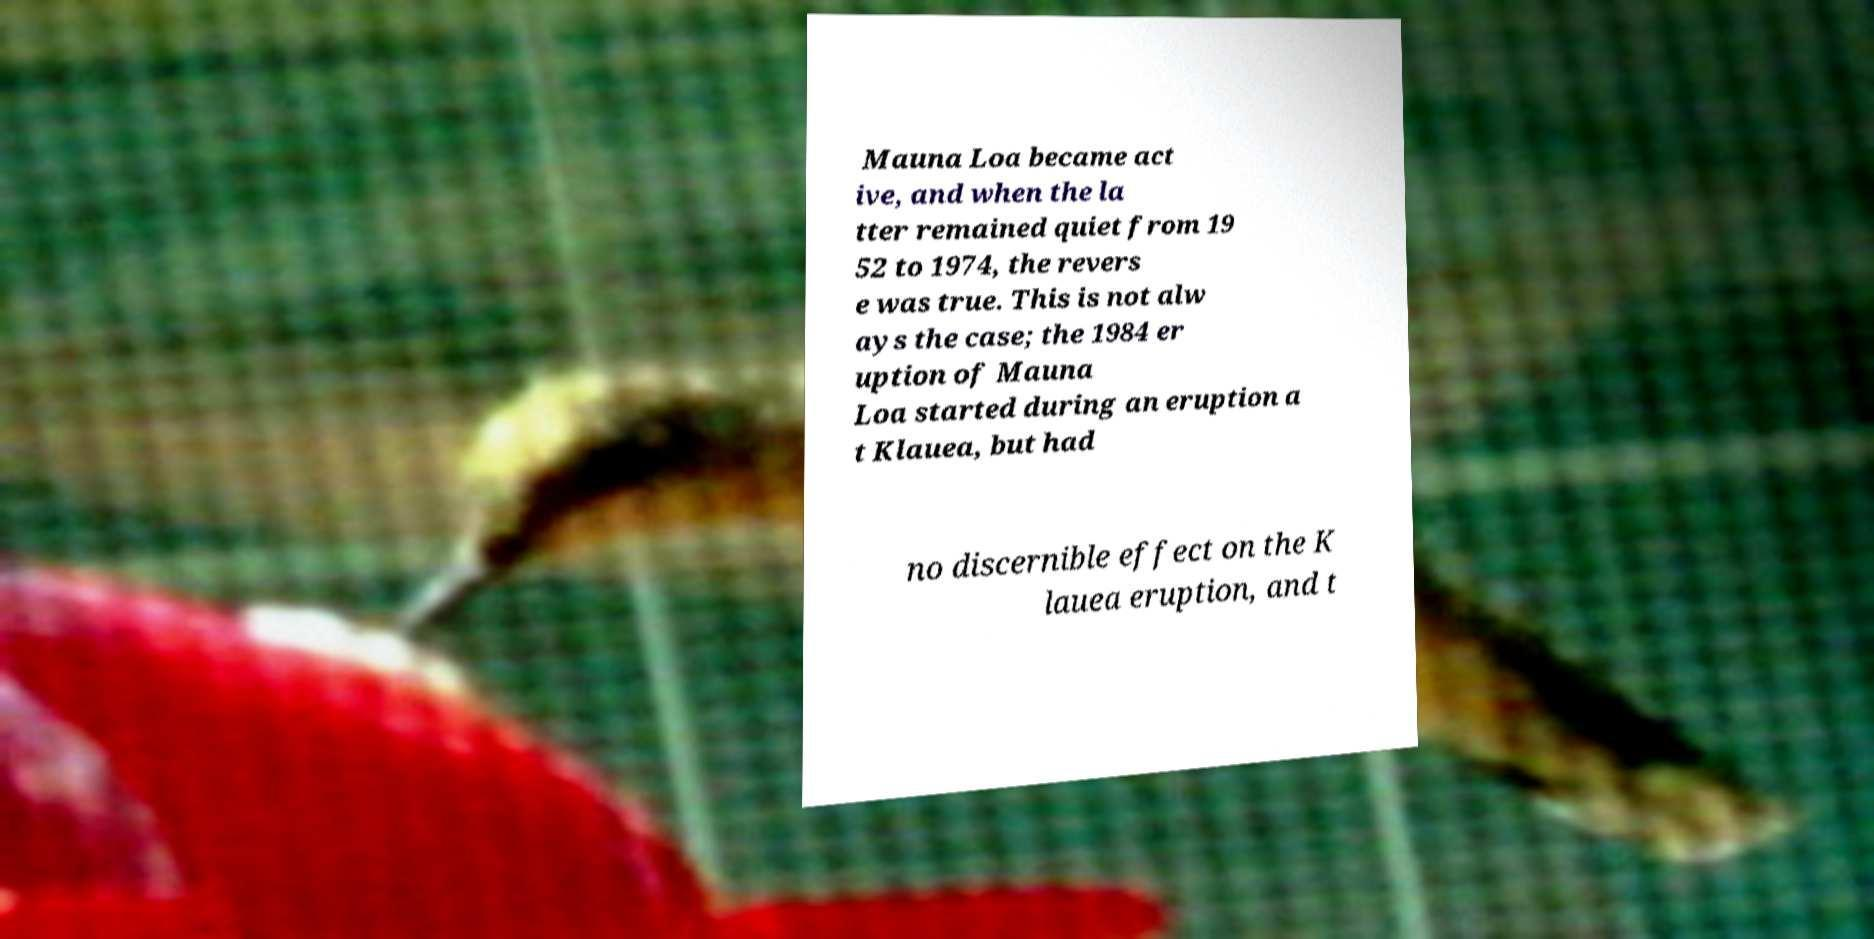Can you read and provide the text displayed in the image?This photo seems to have some interesting text. Can you extract and type it out for me? Mauna Loa became act ive, and when the la tter remained quiet from 19 52 to 1974, the revers e was true. This is not alw ays the case; the 1984 er uption of Mauna Loa started during an eruption a t Klauea, but had no discernible effect on the K lauea eruption, and t 